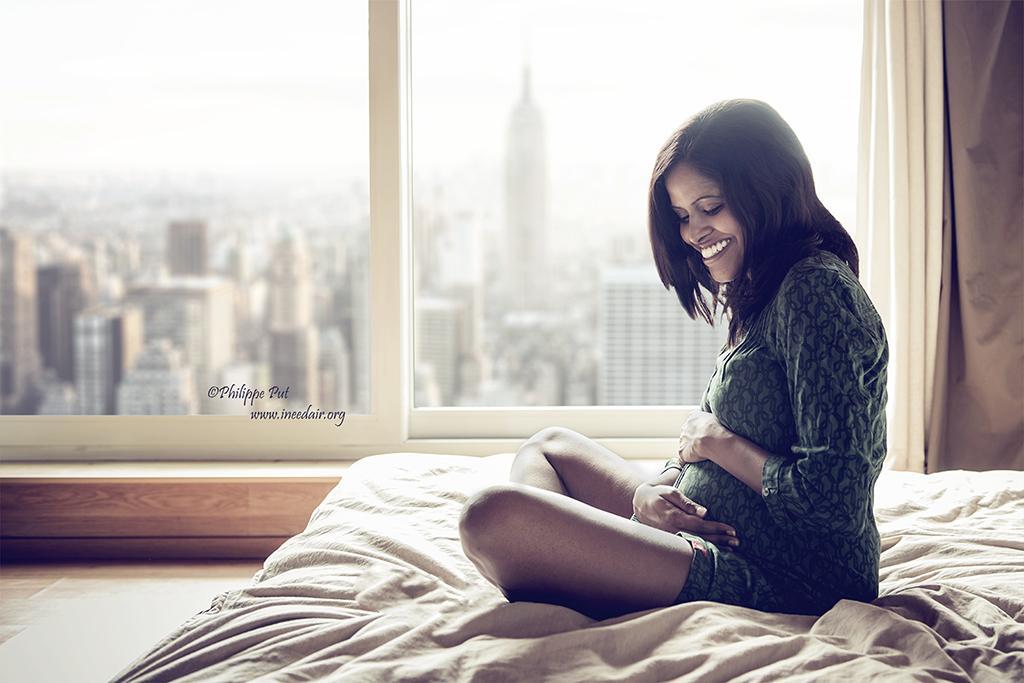Can you describe this image briefly? In this picture I can see a woman smiling and sitting on the blanket of the bed, and in the background there is a window and a curtain. Through the window I can see buildings, there is the sky and there is a watermark on the image. 